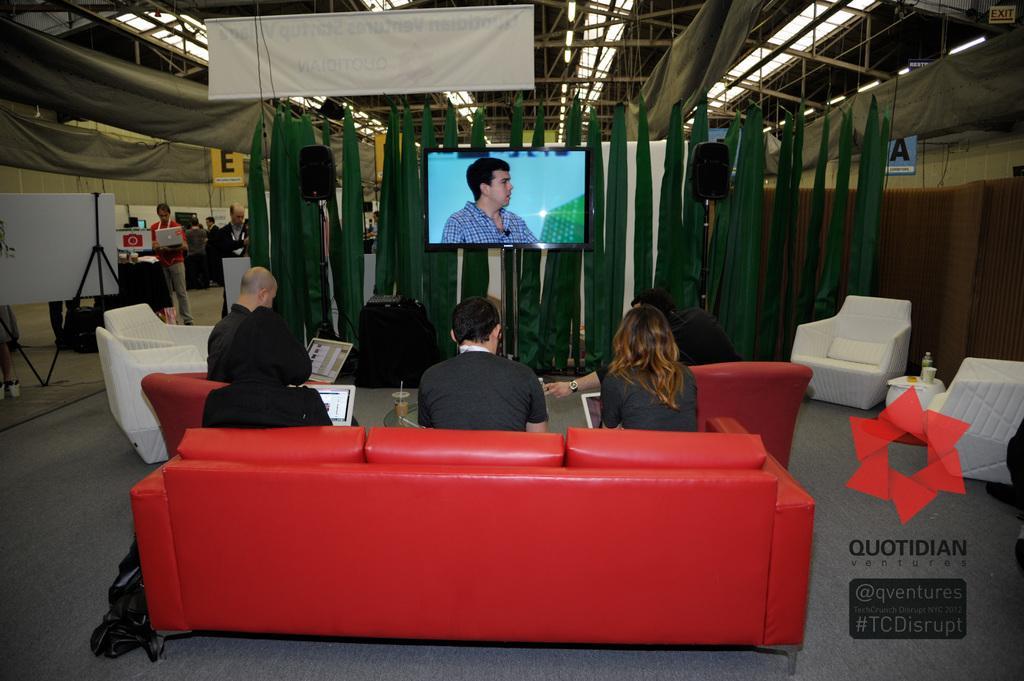Describe this image in one or two sentences. In this picture we can see a group of people some are sitting on sofa and some are standing carrying their laptops and in front of them there is screen to wall, banner, pillar, wall. 